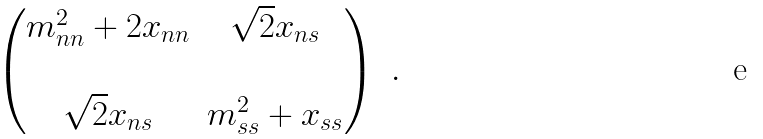Convert formula to latex. <formula><loc_0><loc_0><loc_500><loc_500>\begin{pmatrix} m _ { n n } ^ { 2 } + 2 x _ { n n } & \sqrt { 2 } x _ { n s } \\ & \\ \sqrt { 2 } x _ { n s } & m _ { s s } ^ { 2 } + x _ { s s } \end{pmatrix} \ .</formula> 